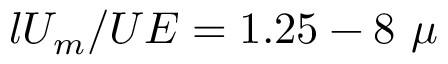<formula> <loc_0><loc_0><loc_500><loc_500>l U _ { m } / U E = 1 . 2 5 - 8 \ \mu</formula> 